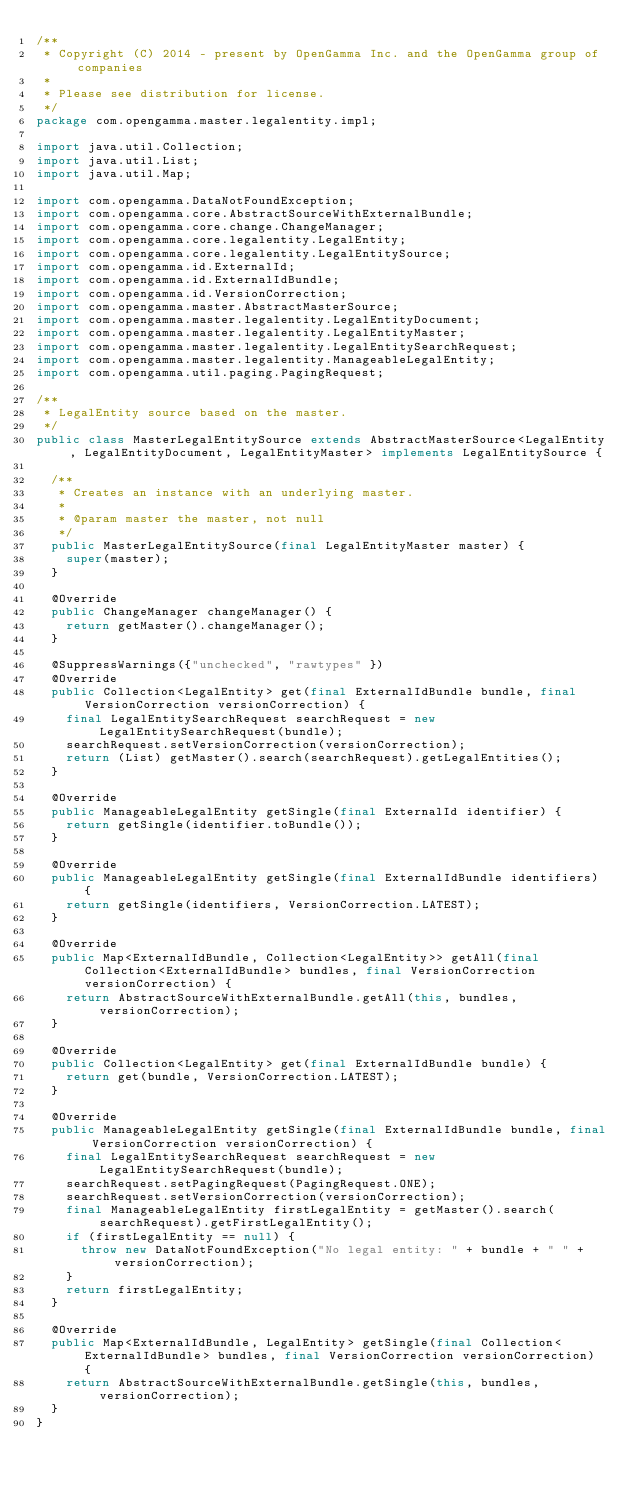Convert code to text. <code><loc_0><loc_0><loc_500><loc_500><_Java_>/**
 * Copyright (C) 2014 - present by OpenGamma Inc. and the OpenGamma group of companies
 *
 * Please see distribution for license.
 */
package com.opengamma.master.legalentity.impl;

import java.util.Collection;
import java.util.List;
import java.util.Map;

import com.opengamma.DataNotFoundException;
import com.opengamma.core.AbstractSourceWithExternalBundle;
import com.opengamma.core.change.ChangeManager;
import com.opengamma.core.legalentity.LegalEntity;
import com.opengamma.core.legalentity.LegalEntitySource;
import com.opengamma.id.ExternalId;
import com.opengamma.id.ExternalIdBundle;
import com.opengamma.id.VersionCorrection;
import com.opengamma.master.AbstractMasterSource;
import com.opengamma.master.legalentity.LegalEntityDocument;
import com.opengamma.master.legalentity.LegalEntityMaster;
import com.opengamma.master.legalentity.LegalEntitySearchRequest;
import com.opengamma.master.legalentity.ManageableLegalEntity;
import com.opengamma.util.paging.PagingRequest;

/**
 * LegalEntity source based on the master.
 */
public class MasterLegalEntitySource extends AbstractMasterSource<LegalEntity, LegalEntityDocument, LegalEntityMaster> implements LegalEntitySource {

  /**
   * Creates an instance with an underlying master.
   *
   * @param master the master, not null
   */
  public MasterLegalEntitySource(final LegalEntityMaster master) {
    super(master);
  }

  @Override
  public ChangeManager changeManager() {
    return getMaster().changeManager();
  }

  @SuppressWarnings({"unchecked", "rawtypes" })
  @Override
  public Collection<LegalEntity> get(final ExternalIdBundle bundle, final VersionCorrection versionCorrection) {
    final LegalEntitySearchRequest searchRequest = new LegalEntitySearchRequest(bundle);
    searchRequest.setVersionCorrection(versionCorrection);
    return (List) getMaster().search(searchRequest).getLegalEntities();
  }

  @Override
  public ManageableLegalEntity getSingle(final ExternalId identifier) {
    return getSingle(identifier.toBundle());
  }

  @Override
  public ManageableLegalEntity getSingle(final ExternalIdBundle identifiers) {
    return getSingle(identifiers, VersionCorrection.LATEST);
  }

  @Override
  public Map<ExternalIdBundle, Collection<LegalEntity>> getAll(final Collection<ExternalIdBundle> bundles, final VersionCorrection versionCorrection) {
    return AbstractSourceWithExternalBundle.getAll(this, bundles, versionCorrection);
  }

  @Override
  public Collection<LegalEntity> get(final ExternalIdBundle bundle) {
    return get(bundle, VersionCorrection.LATEST);
  }

  @Override
  public ManageableLegalEntity getSingle(final ExternalIdBundle bundle, final VersionCorrection versionCorrection) {
    final LegalEntitySearchRequest searchRequest = new LegalEntitySearchRequest(bundle);
    searchRequest.setPagingRequest(PagingRequest.ONE);
    searchRequest.setVersionCorrection(versionCorrection);
    final ManageableLegalEntity firstLegalEntity = getMaster().search(searchRequest).getFirstLegalEntity();
    if (firstLegalEntity == null) {
      throw new DataNotFoundException("No legal entity: " + bundle + " " + versionCorrection);
    }
    return firstLegalEntity;
  }

  @Override
  public Map<ExternalIdBundle, LegalEntity> getSingle(final Collection<ExternalIdBundle> bundles, final VersionCorrection versionCorrection) {
    return AbstractSourceWithExternalBundle.getSingle(this, bundles, versionCorrection);
  }
}
</code> 